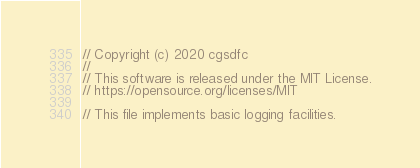<code> <loc_0><loc_0><loc_500><loc_500><_C_>// Copyright (c) 2020 cgsdfc
// 
// This software is released under the MIT License.
// https://opensource.org/licenses/MIT

// This file implements basic logging facilities.
</code> 